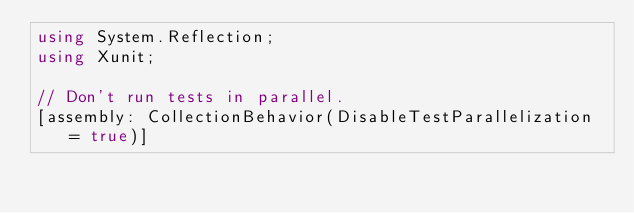<code> <loc_0><loc_0><loc_500><loc_500><_C#_>using System.Reflection;
using Xunit;

// Don't run tests in parallel.
[assembly: CollectionBehavior(DisableTestParallelization = true)]
</code> 